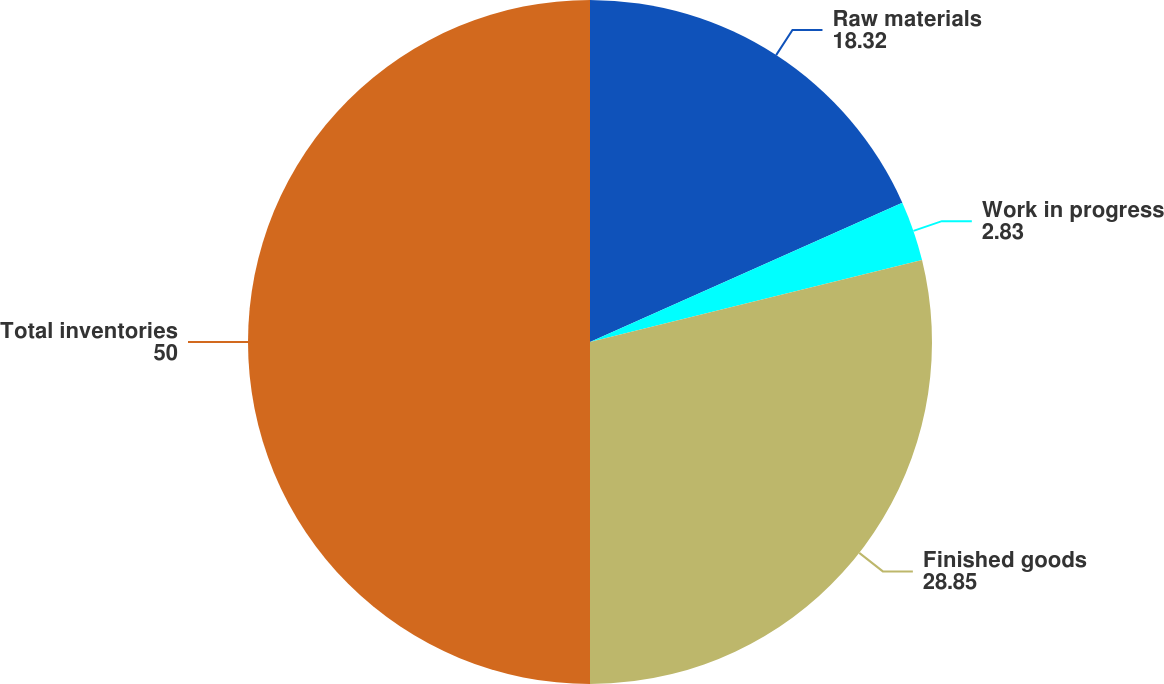Convert chart. <chart><loc_0><loc_0><loc_500><loc_500><pie_chart><fcel>Raw materials<fcel>Work in progress<fcel>Finished goods<fcel>Total inventories<nl><fcel>18.32%<fcel>2.83%<fcel>28.85%<fcel>50.0%<nl></chart> 